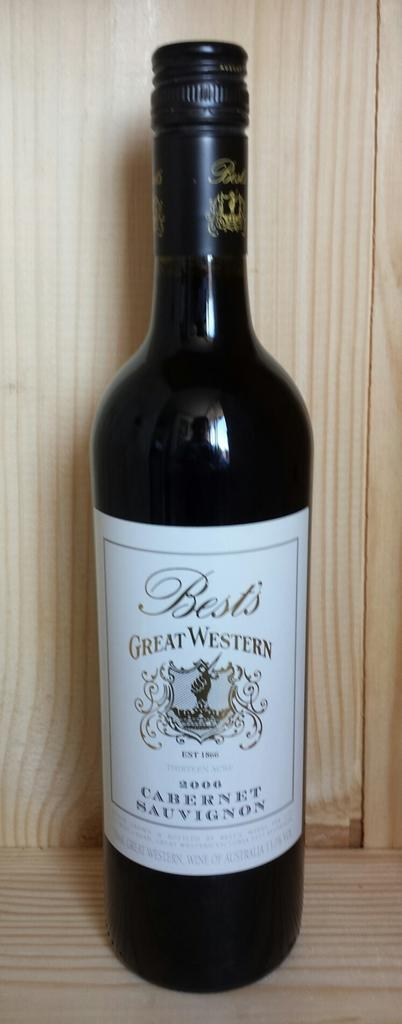<image>
Share a concise interpretation of the image provided. the word Great that is on a wine bottle 